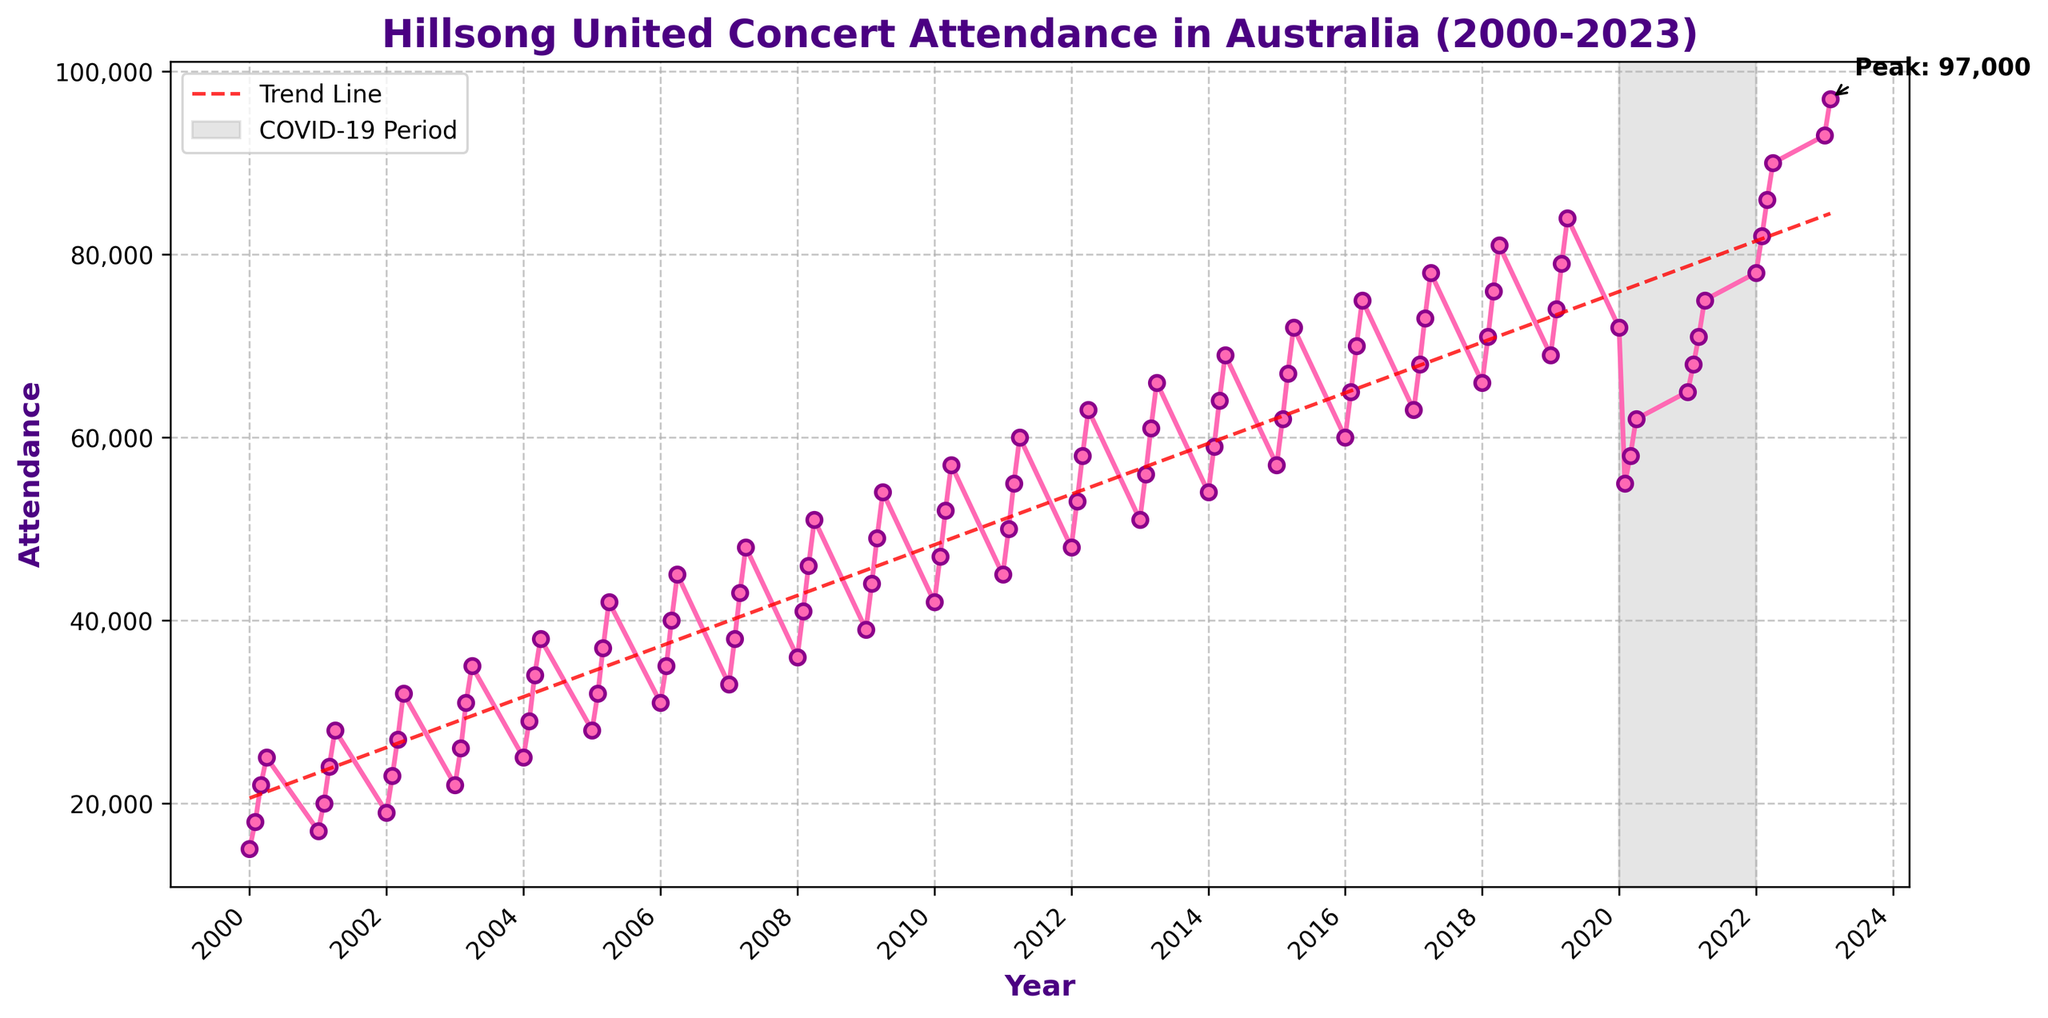What is the general trend in attendance at Hillsong United concerts in Australia from 2000 to 2023? The general trend can be seen in the line slowly rising from 2000 to 2023. Additionally, there's a red dashed trend line that shows an upward trajectory over the years.
Answer: Upward trend In what year did the attendance peak, and what was the attendance number? The peak attendance is highlighted with an annotation. This occurs in 2023, with the attendance number noted near the peak point.
Answer: 2023, 97,000 How did the COVID-19 period impact the attendance at Hillsong United concerts from 2020 to 2021? The COVID-19 period is highlighted with a gray shaded area from 2020 to 2021. During this period, there is a notable dip in attendance compared to the years before and after.
Answer: Decreased attendance What is the average attendance for the years 2020 through 2023? Sum the attendance for the quarters in the years 2020 to 2023 and divide by the number of data points. (72,000+55,000+58,000+62,000+65,000+68,000+71,000+75,000+78,000+82,000+86,000+90,000+93,000+97,000)/16 = 1,052,000/16 = 65,750
Answer: 65,750 How does the Q4 attendance in 2020 compare to Q4 attendance in 2021? Look at the attendance values for Q4 in both years. Compare the numbers directly: 62,000 (2020) vs 75,000 (2021) shows an increase.
Answer: Increased Which quarter consistently has the highest attendance over the entire period? By looking at each quarter's attendance values over the years, Q4 consistently shows an increase and higher attendance numbers compared to other quarters.
Answer: Q4 What was the rate of increase in attendance from Q1 2022 to Q1 2023? Calculate the difference between the attendance of Q1 2023 and Q1 2022, and then find the ratio of this difference to the Q1 2022 attendance: (93,000 - 78,000) / 78,000.
Answer: 19.2% What color is used to represent the trend line? The trend line is visually indicated in the plot. It is shown with a dashed line in red.
Answer: Red Is there a noticeable pattern in seasonality in concert attendance? Referring to the plot, a seasonality pattern is apparent where certain quarters, specifically Q4, usually have higher attendance.
Answer: Yes, Q4 is higher 